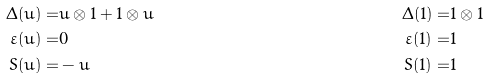<formula> <loc_0><loc_0><loc_500><loc_500>\Delta ( u ) = & u \otimes 1 + 1 \otimes u & \Delta ( 1 ) = & 1 \otimes 1 \\ \varepsilon ( u ) = & 0 & \varepsilon ( 1 ) = & 1 \\ S ( u ) = & - u & S ( 1 ) = & 1</formula> 